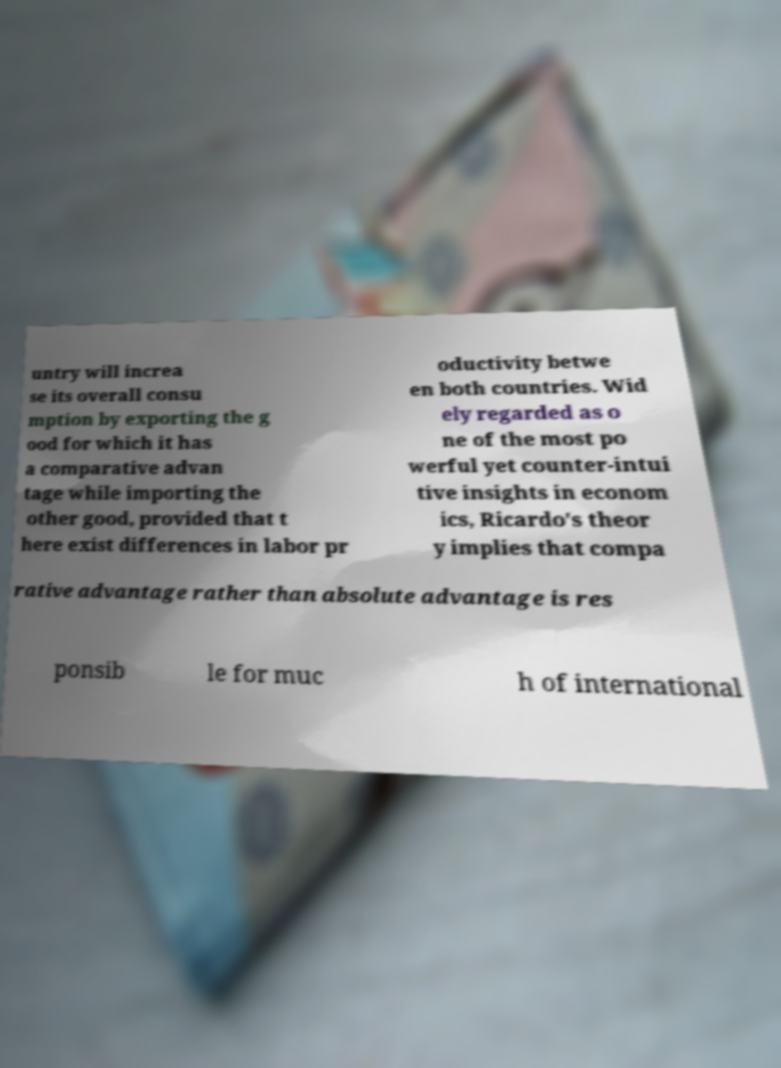Can you read and provide the text displayed in the image?This photo seems to have some interesting text. Can you extract and type it out for me? untry will increa se its overall consu mption by exporting the g ood for which it has a comparative advan tage while importing the other good, provided that t here exist differences in labor pr oductivity betwe en both countries. Wid ely regarded as o ne of the most po werful yet counter-intui tive insights in econom ics, Ricardo's theor y implies that compa rative advantage rather than absolute advantage is res ponsib le for muc h of international 